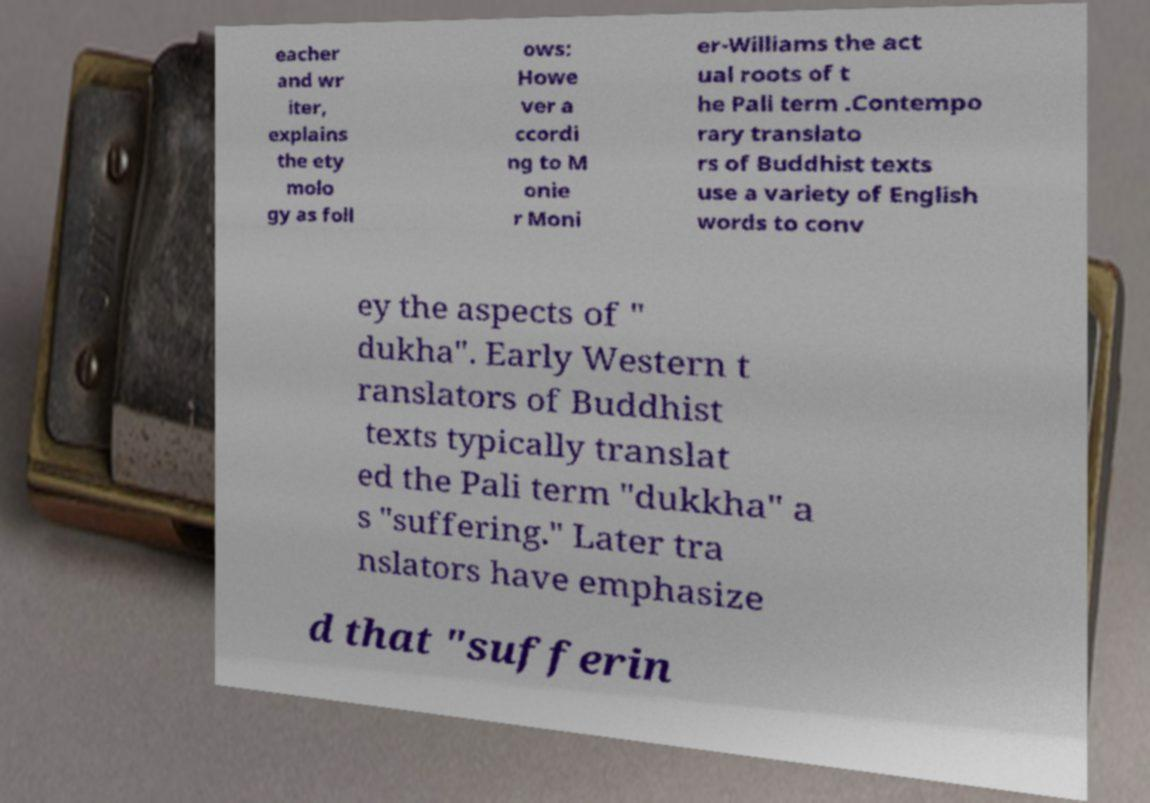Please identify and transcribe the text found in this image. eacher and wr iter, explains the ety molo gy as foll ows: Howe ver a ccordi ng to M onie r Moni er-Williams the act ual roots of t he Pali term .Contempo rary translato rs of Buddhist texts use a variety of English words to conv ey the aspects of " dukha". Early Western t ranslators of Buddhist texts typically translat ed the Pali term "dukkha" a s "suffering." Later tra nslators have emphasize d that "sufferin 